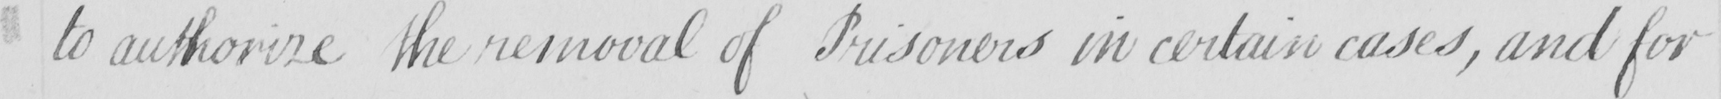What does this handwritten line say? to authorize the removal of Prisoners in certain cases , and for 